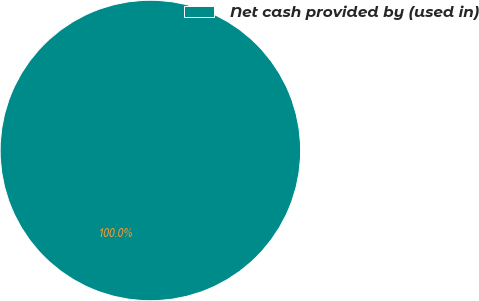<chart> <loc_0><loc_0><loc_500><loc_500><pie_chart><fcel>Net cash provided by (used in)<nl><fcel>100.0%<nl></chart> 